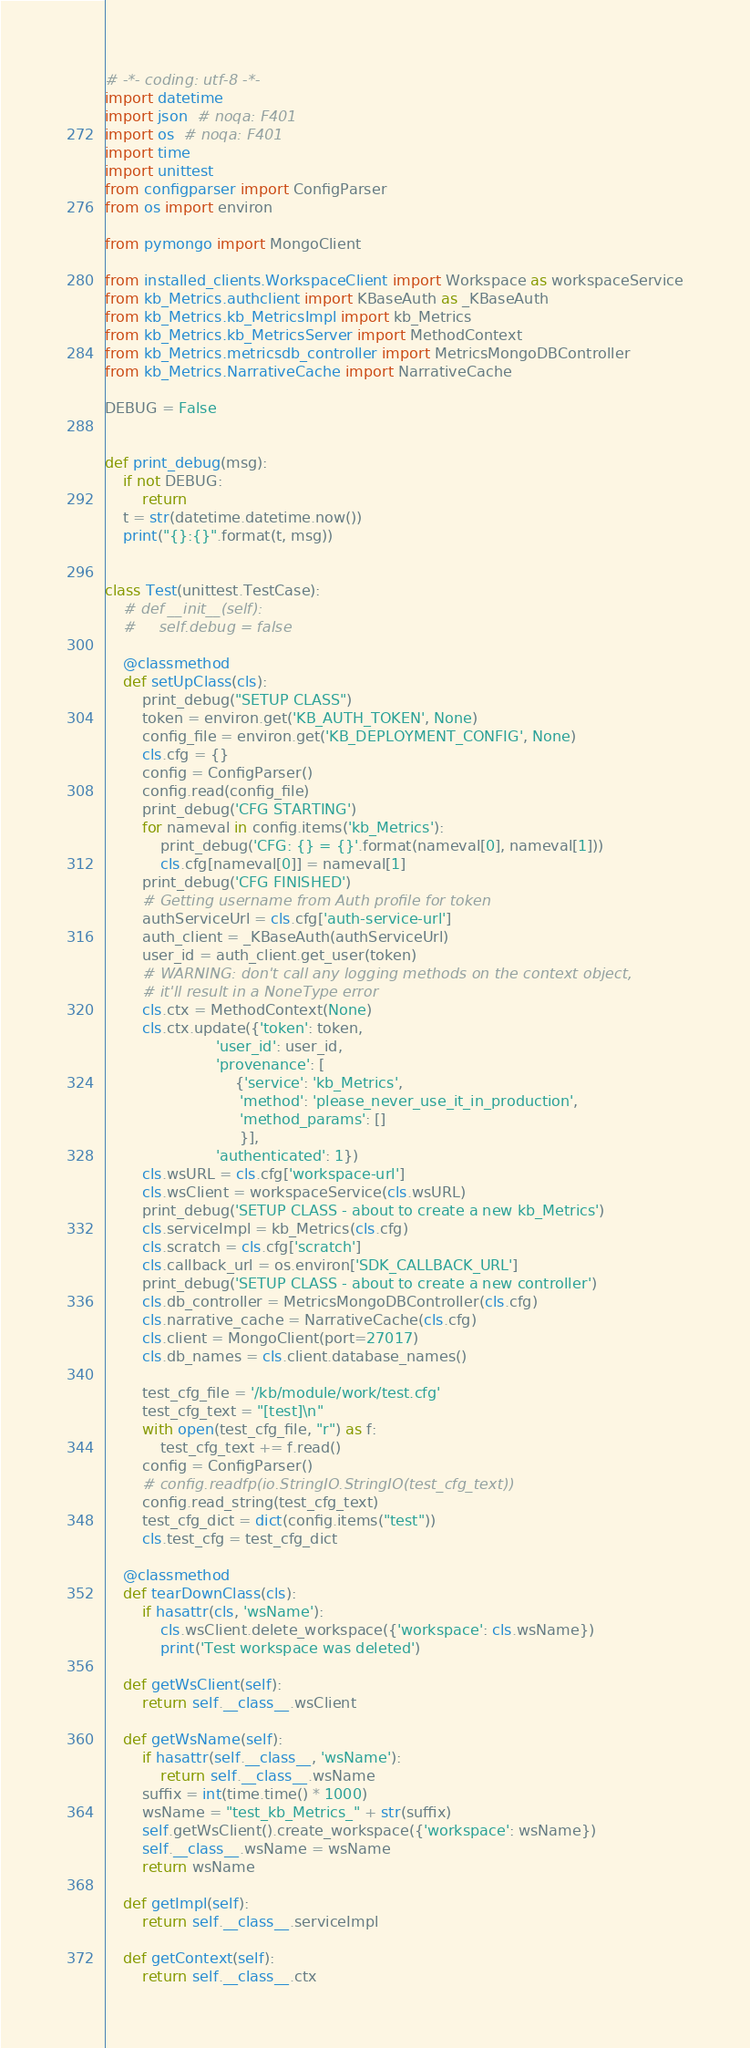Convert code to text. <code><loc_0><loc_0><loc_500><loc_500><_Python_># -*- coding: utf-8 -*-
import datetime
import json  # noqa: F401
import os  # noqa: F401
import time
import unittest
from configparser import ConfigParser
from os import environ

from pymongo import MongoClient

from installed_clients.WorkspaceClient import Workspace as workspaceService
from kb_Metrics.authclient import KBaseAuth as _KBaseAuth
from kb_Metrics.kb_MetricsImpl import kb_Metrics
from kb_Metrics.kb_MetricsServer import MethodContext
from kb_Metrics.metricsdb_controller import MetricsMongoDBController
from kb_Metrics.NarrativeCache import NarrativeCache

DEBUG = False


def print_debug(msg):
    if not DEBUG:
        return
    t = str(datetime.datetime.now())
    print("{}:{}".format(t, msg))


class Test(unittest.TestCase):
    # def __init__(self):
    #     self.debug = false

    @classmethod
    def setUpClass(cls):
        print_debug("SETUP CLASS")
        token = environ.get('KB_AUTH_TOKEN', None)
        config_file = environ.get('KB_DEPLOYMENT_CONFIG', None)
        cls.cfg = {}
        config = ConfigParser()
        config.read(config_file)
        print_debug('CFG STARTING')
        for nameval in config.items('kb_Metrics'):
            print_debug('CFG: {} = {}'.format(nameval[0], nameval[1]))
            cls.cfg[nameval[0]] = nameval[1]
        print_debug('CFG FINISHED')
        # Getting username from Auth profile for token
        authServiceUrl = cls.cfg['auth-service-url']
        auth_client = _KBaseAuth(authServiceUrl)
        user_id = auth_client.get_user(token)
        # WARNING: don't call any logging methods on the context object,
        # it'll result in a NoneType error
        cls.ctx = MethodContext(None)
        cls.ctx.update({'token': token,
                        'user_id': user_id,
                        'provenance': [
                            {'service': 'kb_Metrics',
                             'method': 'please_never_use_it_in_production',
                             'method_params': []
                             }],
                        'authenticated': 1})
        cls.wsURL = cls.cfg['workspace-url']
        cls.wsClient = workspaceService(cls.wsURL)
        print_debug('SETUP CLASS - about to create a new kb_Metrics')
        cls.serviceImpl = kb_Metrics(cls.cfg)
        cls.scratch = cls.cfg['scratch']
        cls.callback_url = os.environ['SDK_CALLBACK_URL']
        print_debug('SETUP CLASS - about to create a new controller')
        cls.db_controller = MetricsMongoDBController(cls.cfg)
        cls.narrative_cache = NarrativeCache(cls.cfg)
        cls.client = MongoClient(port=27017)
        cls.db_names = cls.client.database_names()

        test_cfg_file = '/kb/module/work/test.cfg'
        test_cfg_text = "[test]\n"
        with open(test_cfg_file, "r") as f:
            test_cfg_text += f.read()
        config = ConfigParser()
        # config.readfp(io.StringIO.StringIO(test_cfg_text))
        config.read_string(test_cfg_text)
        test_cfg_dict = dict(config.items("test"))
        cls.test_cfg = test_cfg_dict

    @classmethod
    def tearDownClass(cls):
        if hasattr(cls, 'wsName'):
            cls.wsClient.delete_workspace({'workspace': cls.wsName})
            print('Test workspace was deleted')

    def getWsClient(self):
        return self.__class__.wsClient

    def getWsName(self):
        if hasattr(self.__class__, 'wsName'):
            return self.__class__.wsName
        suffix = int(time.time() * 1000)
        wsName = "test_kb_Metrics_" + str(suffix)
        self.getWsClient().create_workspace({'workspace': wsName})
        self.__class__.wsName = wsName
        return wsName

    def getImpl(self):
        return self.__class__.serviceImpl

    def getContext(self):
        return self.__class__.ctx
</code> 